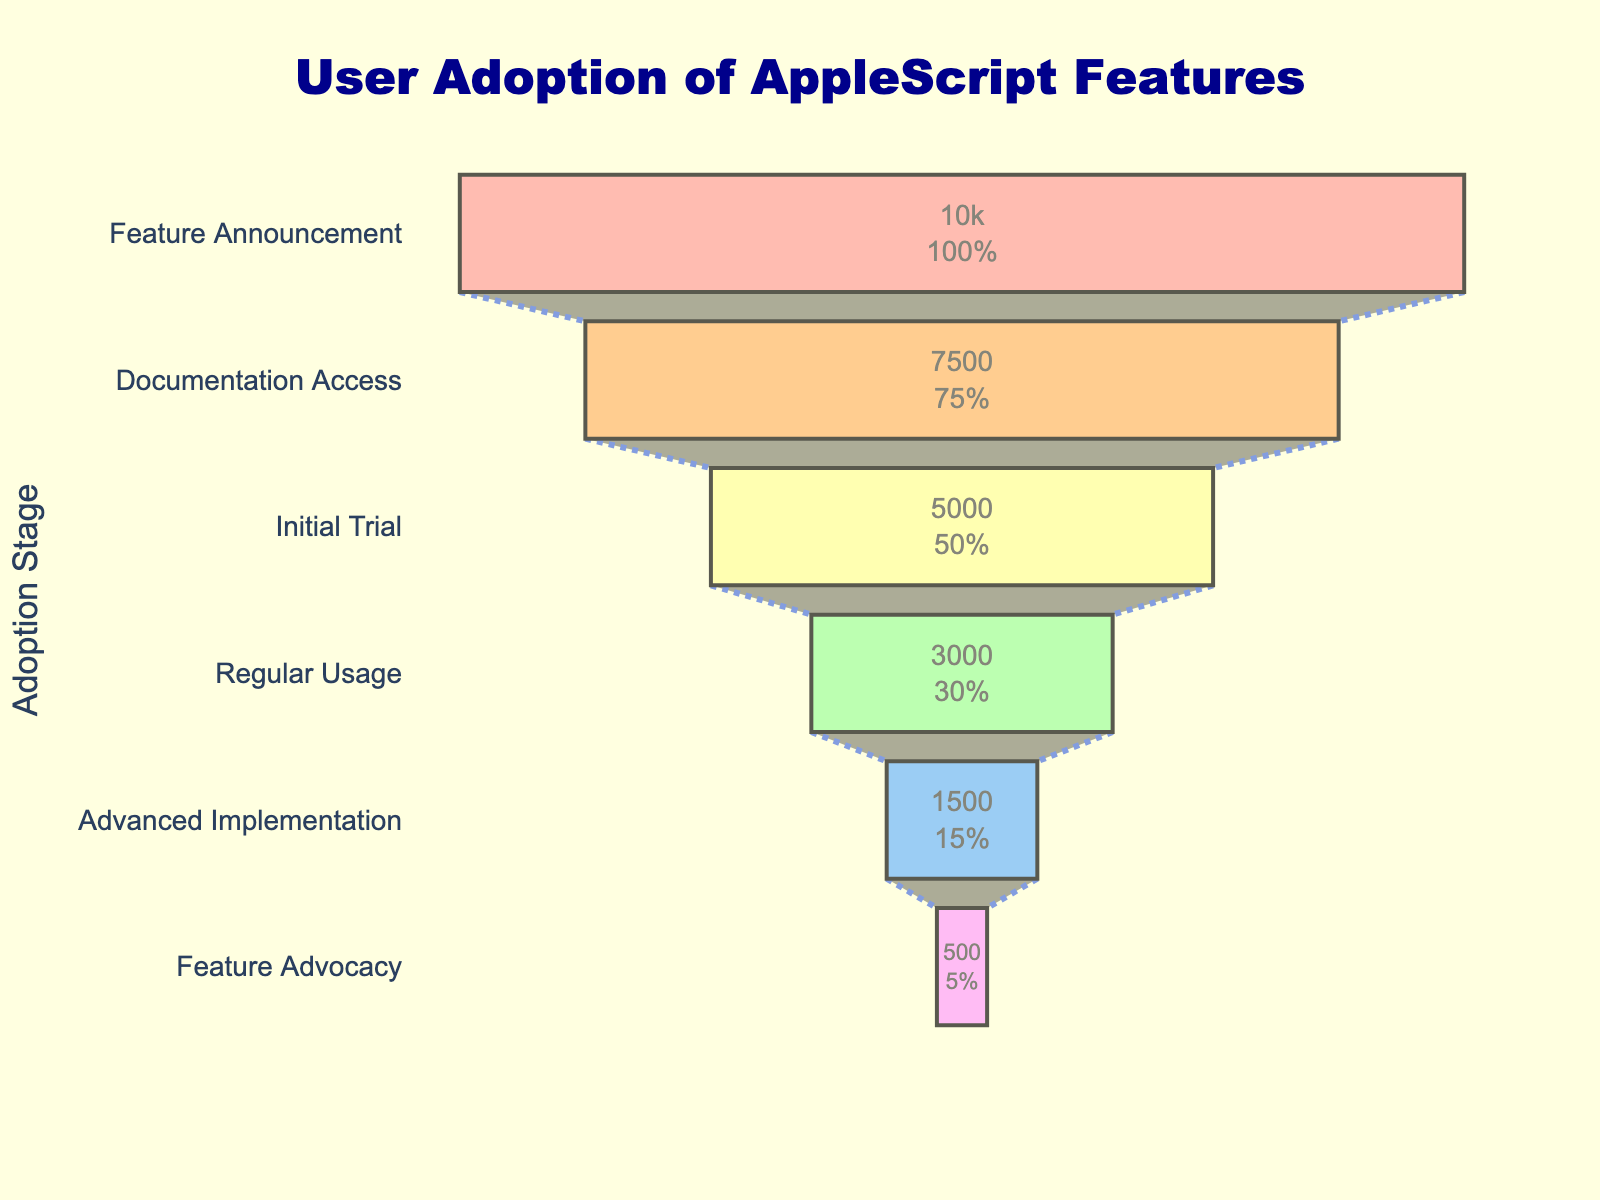What is the title of the figure? The title is usually displayed at the top of the figure. In this case, it states what the figure is about.
Answer: User Adoption of AppleScript Features What are the stages listed in the funnel chart? The stages are labeled on the y-axis of the funnel chart. These labels indicate the different phases the users go through.
Answer: Feature Announcement, Documentation Access, Initial Trial, Regular Usage, Advanced Implementation, Feature Advocacy How many users accessed the documentation? The number of users for the Documentation Access stage is shown by the corresponding bar's value.
Answer: 7500 Which stage has the lowest number of users and how many users are there? Look at the stages and their corresponding user counts; the stage with the smallest value is the answer.
Answer: Feature Advocacy, 500 What percentage of users moved from Feature Announcement to Documentation Access? The funnel chart usually displays the percentage of users moving between stages. For this, divide the number of users in Documentation Access (7500) by the number of users in Feature Announcement (10000) and multiply by 100.
Answer: 75% How many fewer users are at Regular Usage compared to Initial Trial? Subtract the number of users in Regular Usage (3000) from the number of users in Initial Trial (5000).
Answer: 2000 Which stage saw the highest drop in user count, and what is the actual difference? Calculate the absolute differences between subsequent stages; the stage with the highest difference is the answer. For example, the difference between Initial Trial and Regular Usage is 2000.
Answer: Documentation Access to Initial Trial, 2500 What is the color of the bar representing the Feature Advocacy stage? Identify the color pattern used in the bars and locate the specific color for the Feature Advocacy stage.
Answer: Pink (or specify the exact shade if described in the figure) How many users progressed to Advanced Implementation from Regular Usage? The number of users for Advanced Implementation is indicated in the funnel chart.
Answer: 1500 What is the percentage of users who became regular users out of those who initially tried the feature? Divide the number of Regular Usage users (3000) by the number of Initial Trial users (5000) and multiply by 100 to get the percentage.
Answer: 60% 